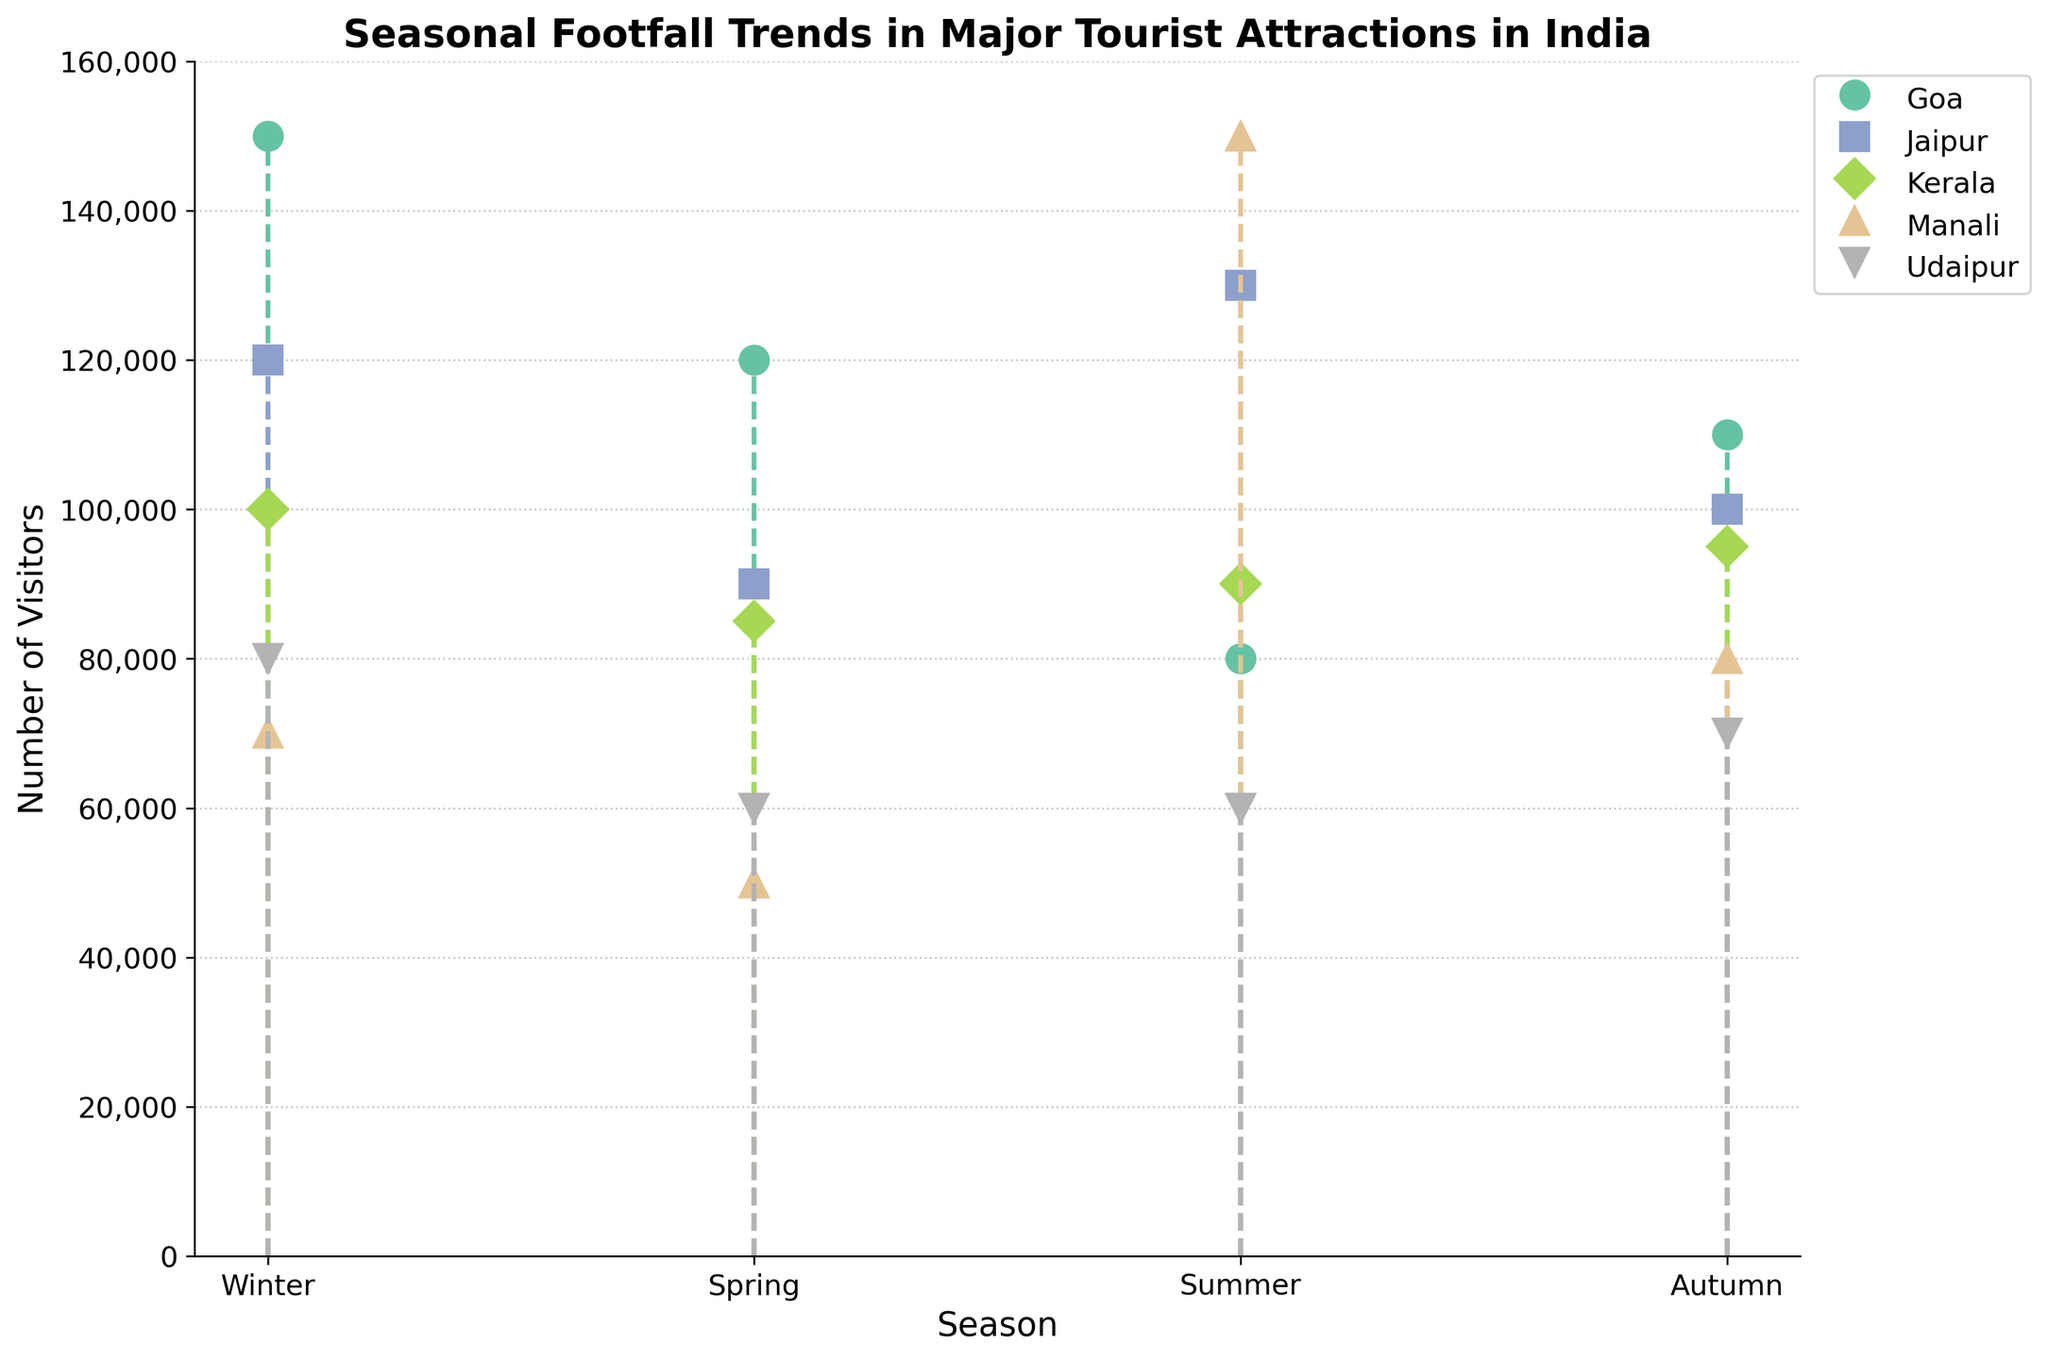What does the y-axis represent? The y-axis in the plot represents the "Number of Visitors." It quantifies the number of people visiting each location during a specific season.
Answer: Number of Visitors Which season has the highest footfall in Manali? To find the season with the highest footfall in Manali, look at the stem plot data points for Manali across all seasons. The highest value is 150,000 visitors in summer.
Answer: Summer Compare the number of visitors in Goa during winter and summer. The plot shows that Goa had 150,000 visitors in winter and 80,000 visitors in summer. To find the difference, subtract the summer value from the winter value: 150,000 - 80,000 = 70,000.
Answer: Winter has 70,000 more visitors What is the average number of visitors in Udaipur across all seasons? First, add the number of visitors in Udaipur across all seasons: 80,000 (Winter) + 60,000 (Spring) + 60,000 (Summer) + 70,000 (Autumn) = 270,000. Then, divide by the number of seasons: 270,000 / 4 = 67,500.
Answer: 67,500 Which location has a decrease in visitors from winter to spring? To identify locations with a decrease in visitors from winter to spring, compare the number of visitors in each location for those two seasons:
- Goa: 150,000 (Winter) to 120,000 (Spring) - Decrease
- Jaipur: 120,000 (Winter) to 90,000 (Spring) - Decrease
- Kerala: 100,000 (Winter) to 85,000 (Spring) - Decrease
- Manali: 70,000 (Winter) to 50,000 (Spring) - Decrease
- Udaipur: 80,000 (Winter) to 60,000 (Spring) - Decrease
All locations show a decrease in visitors from winter to spring.
Answer: All locations Which location has the most consistent number of visitors across all seasons? To determine the location with the most consistent number of visitors, look at the variation in visitor numbers across seasons for each location. Kerala has the smallest range (variation) with visitors close to 100,000 in all seasons: 100,000 (Winter), 85,000 (Spring), 90,000 (Summer), 95,000 (Autumn).
Answer: Kerala How does the number of visitors in Jaipur compare between spring and summer? Spring has 90,000 visitors and summer has 130,000 visitors. Jaipur sees an increase of 40,000 visitors from spring to summer.
Answer: Summer has 40,000 more visitors What is the title of the plot? The title of the plot is displayed at the top and reads "Seasonal Footfall Trends in Major Tourist Attractions in India."
Answer: Seasonal Footfall Trends in Major Tourist Attractions in India Which season shows the highest overall footfall for all locations combined? Sum the total number of visitors in all locations for each season and compare:
- Winter: 150,000 (Goa) + 120,000 (Jaipur) + 100,000 (Kerala) + 70,000 (Manali) + 80,000 (Udaipur) = 520,000
- Spring: 120,000 (Goa) + 90,000 (Jaipur) + 85,000 (Kerala) + 50,000 (Manali) + 60,000 (Udaipur) = 405,000
- Summer: 80,000 (Goa) + 130,000 (Jaipur) + 90,000 (Kerala) + 150,000 (Manali) + 60,000 (Udaipur) = 510,000
- Autumn: 110,000 (Goa) + 100,000 (Jaipur) + 95,000 (Kerala) + 80,000 (Manali) + 70,000 (Udaipur) = 455,000
The highest overall footfall is in Winter.
Answer: Winter 